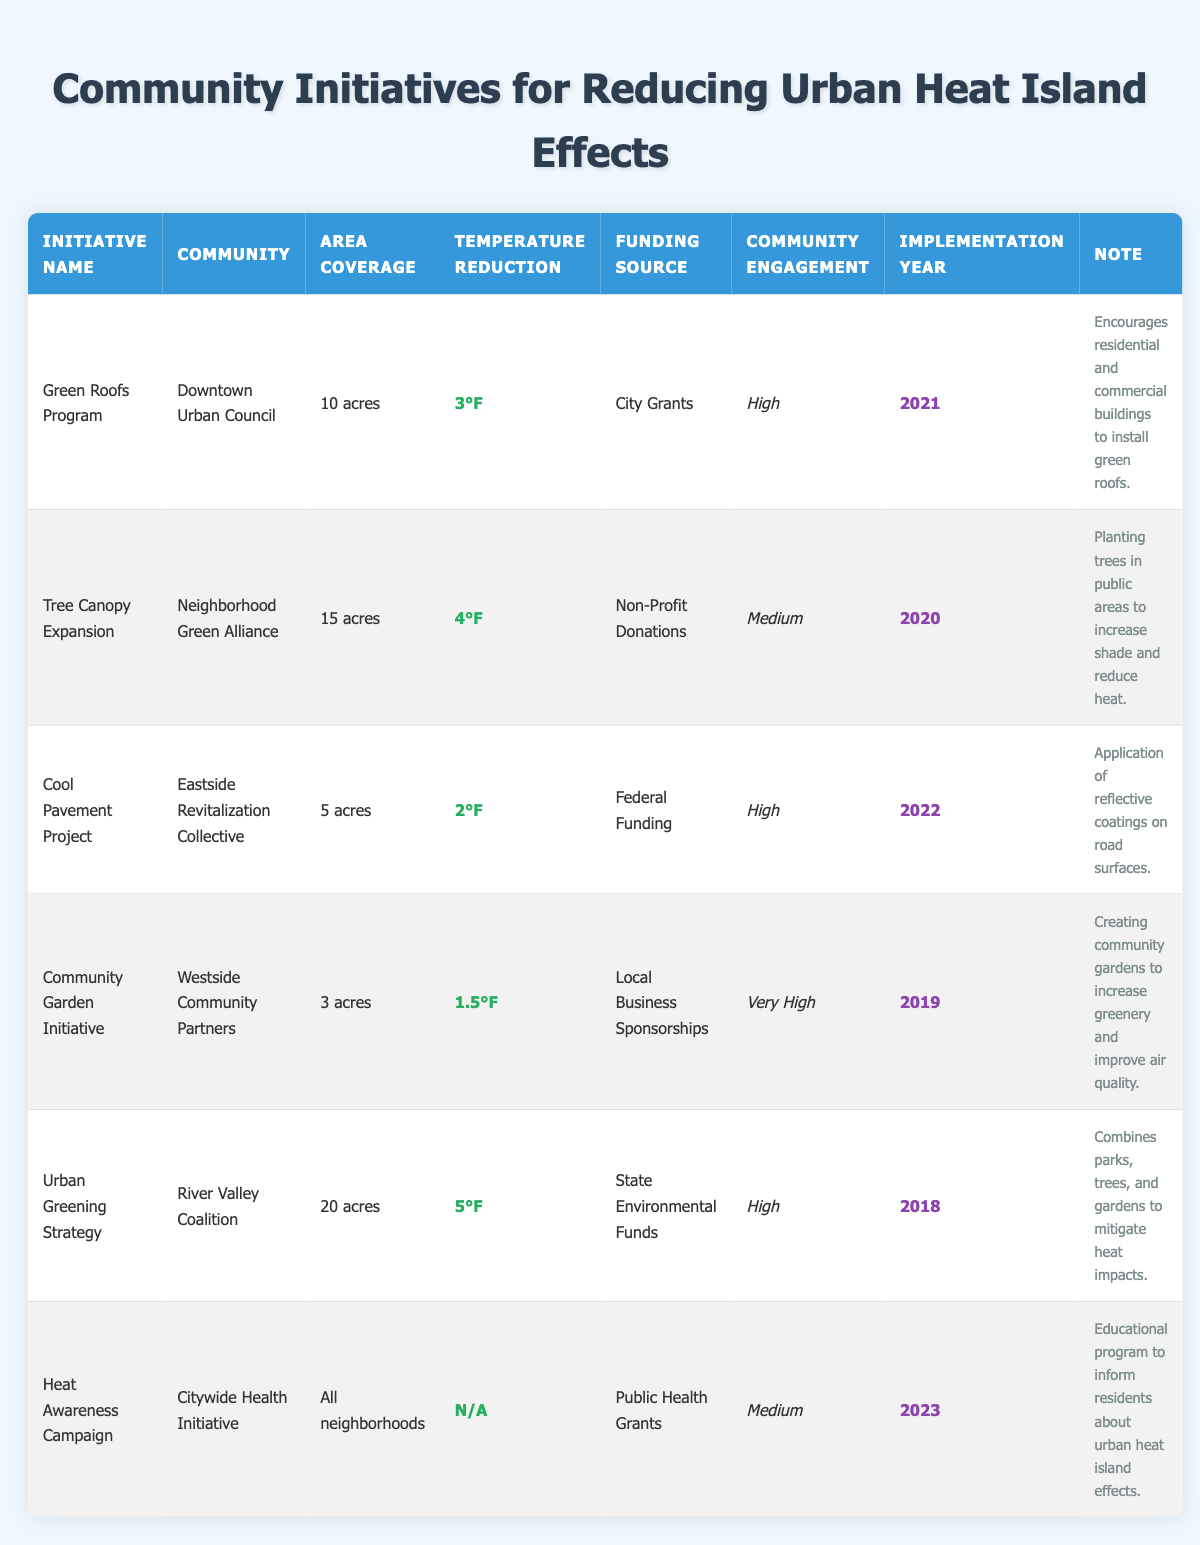What is the temperature reduction achieved by the Urban Greening Strategy? The Urban Greening Strategy's row indicates the temperature reduction is 5°F. This is a basic retrieval question that directly accesses the specific cell in the table.
Answer: 5°F Which initiative has the highest community engagement level? The table shows community engagement levels for each initiative. The Community Garden Initiative has "Very High" community engagement, which is higher than the others listed.
Answer: Community Garden Initiative Total area coverage of all initiatives listed in the table? By adding the area coverage of each initiative, we get: 10 acres + 15 acres + 5 acres + 3 acres + 20 acres + X acres (where X is considered as all neighborhoods for the Heat Awareness Campaign but is ambiguous for calculation). Only integer area values give us 53 acres from the well-defined initiatives.
Answer: 53 acres Was the Cool Pavement Project funded by a city grant? Looking at the funding source for the Cool Pavement Project, it was funded by "Federal Funding," which indicates that it was not funded by a city grant. This is a simple yes or no question.
Answer: No Which initiative was implemented most recently, and what is its funding source? The Heat Awareness Campaign was implemented in 2023. Referring to the corresponding row, the funding source for this initiative is "Public Health Grants." This requires identifying the latest year from the implementation years in the table.
Answer: Heat Awareness Campaign, Public Health Grants How much more temperature reduction does the Tree Canopy Expansion provide compared to the Community Garden Initiative? The Tree Canopy Expansion provides a temperature reduction of 4°F, while the Community Garden Initiative provides 1.5°F. The difference is calculated as 4°F - 1.5°F = 2.5°F. This involves comparing two related data points directly to find the difference.
Answer: 2.5°F 